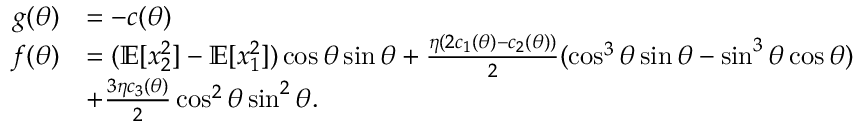Convert formula to latex. <formula><loc_0><loc_0><loc_500><loc_500>\begin{array} { r l } { g ( \theta ) } & { = - c ( \theta ) } \\ { f ( \theta ) } & { = ( \mathbb { E } [ x _ { 2 } ^ { 2 } ] - \mathbb { E } [ x _ { 1 } ^ { 2 } ] ) \cos \theta \sin \theta + \frac { \eta ( 2 c _ { 1 } ( \theta ) - c _ { 2 } ( \theta ) ) } { 2 } ( \cos ^ { 3 } \theta \sin \theta - \sin ^ { 3 } \theta \cos \theta ) } \\ & { + \frac { 3 \eta c _ { 3 } ( \theta ) } { 2 } \cos ^ { 2 } \theta \sin ^ { 2 } \theta . } \end{array}</formula> 